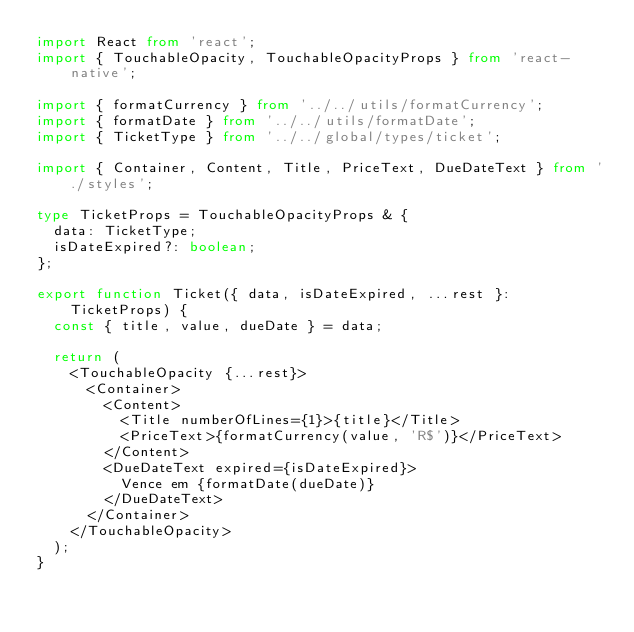Convert code to text. <code><loc_0><loc_0><loc_500><loc_500><_TypeScript_>import React from 'react';
import { TouchableOpacity, TouchableOpacityProps } from 'react-native';

import { formatCurrency } from '../../utils/formatCurrency';
import { formatDate } from '../../utils/formatDate';
import { TicketType } from '../../global/types/ticket';

import { Container, Content, Title, PriceText, DueDateText } from './styles';

type TicketProps = TouchableOpacityProps & {
  data: TicketType;
  isDateExpired?: boolean;
};

export function Ticket({ data, isDateExpired, ...rest }: TicketProps) {
  const { title, value, dueDate } = data;

  return (
    <TouchableOpacity {...rest}>
      <Container>
        <Content>
          <Title numberOfLines={1}>{title}</Title>
          <PriceText>{formatCurrency(value, 'R$')}</PriceText>
        </Content>
        <DueDateText expired={isDateExpired}>
          Vence em {formatDate(dueDate)}
        </DueDateText>
      </Container>
    </TouchableOpacity>
  );
}
</code> 